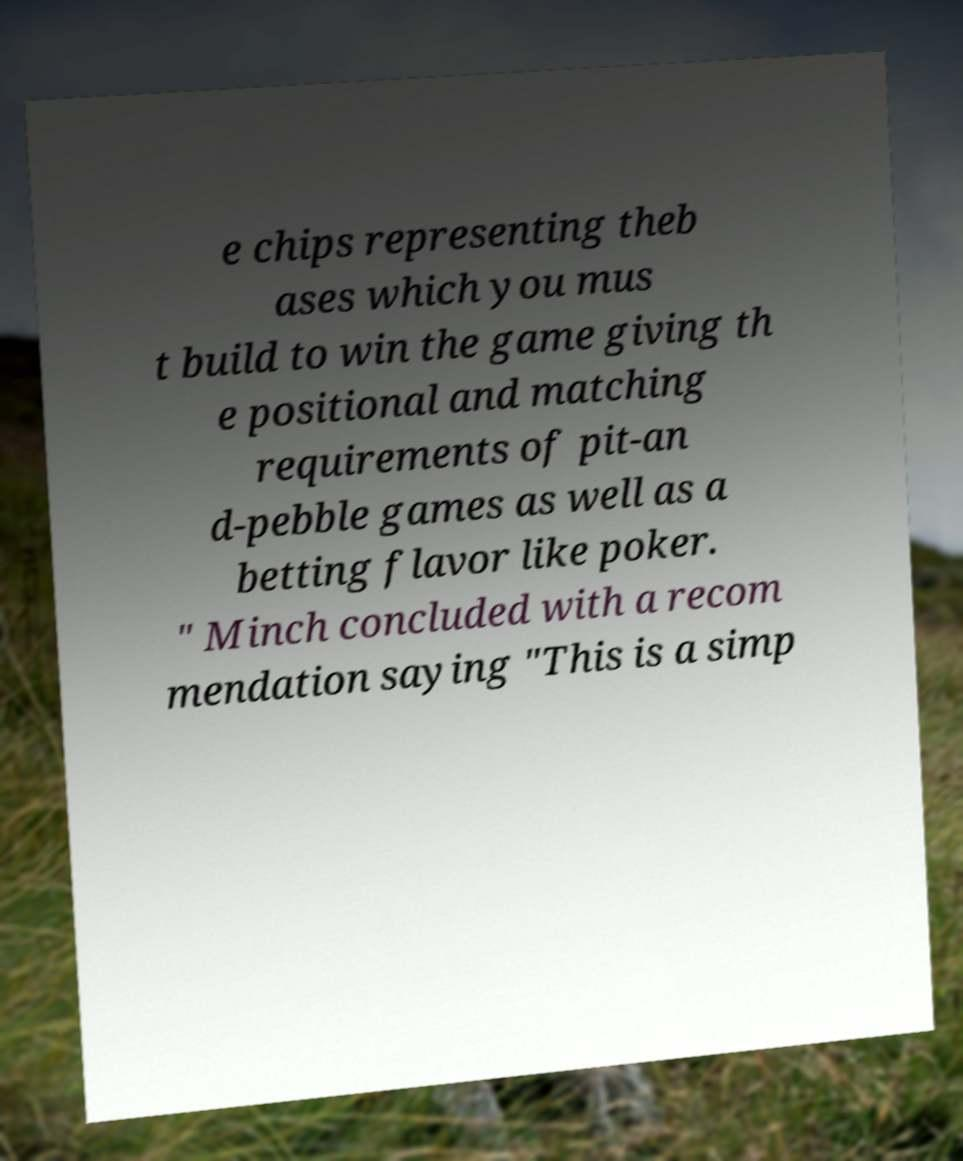Can you read and provide the text displayed in the image?This photo seems to have some interesting text. Can you extract and type it out for me? e chips representing theb ases which you mus t build to win the game giving th e positional and matching requirements of pit-an d-pebble games as well as a betting flavor like poker. " Minch concluded with a recom mendation saying "This is a simp 